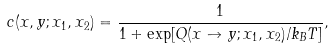<formula> <loc_0><loc_0><loc_500><loc_500>c ( x , y ; x _ { 1 } , x _ { 2 } ) = \frac { 1 } { 1 + \exp [ Q ( x \to y ; x _ { 1 } , x _ { 2 } ) / k _ { B } T ] } ,</formula> 